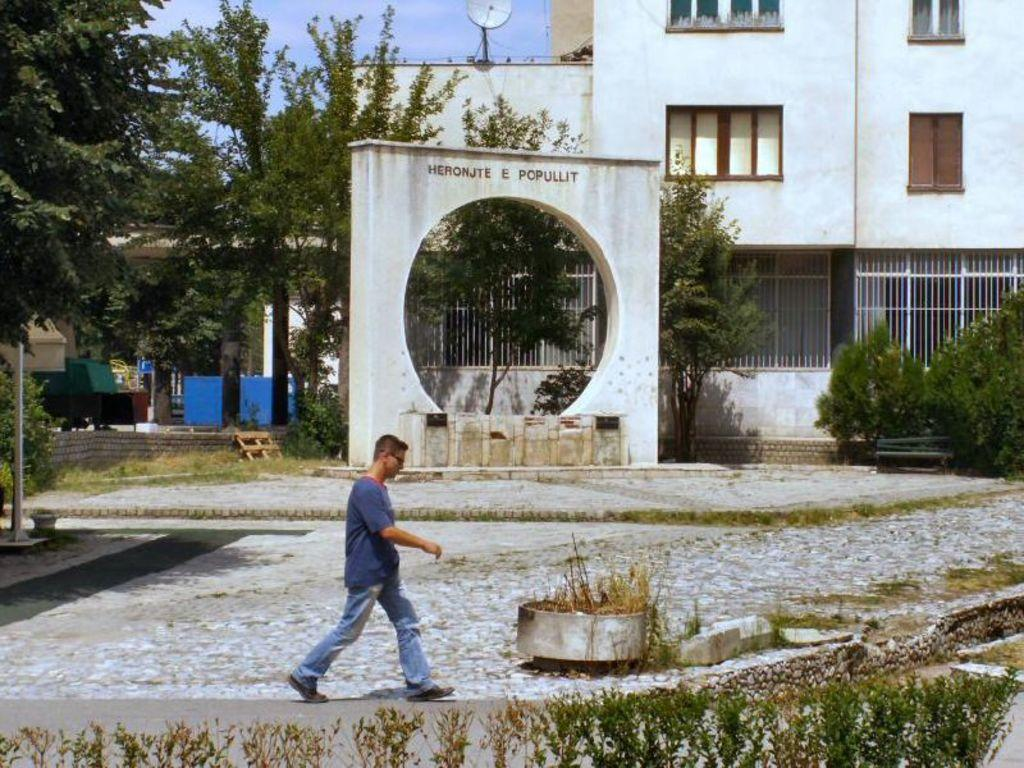What is the person in the image doing? There is a person walking in the image. What type of vegetation can be seen in the image? There are plants, grass, and trees visible in the image. What type of structure is present in the image? There is a bench in the image. What else can be seen in the background of the image? There are buildings, a pole, and an antenna visible in the image. What is visible at the top of the image? The sky is visible in the image. Can you tell me how many tanks are visible in the image? There are no tanks present in the image. What type of farming equipment is being used by the farmer in the image? There is no farmer or farming equipment present in the image. 